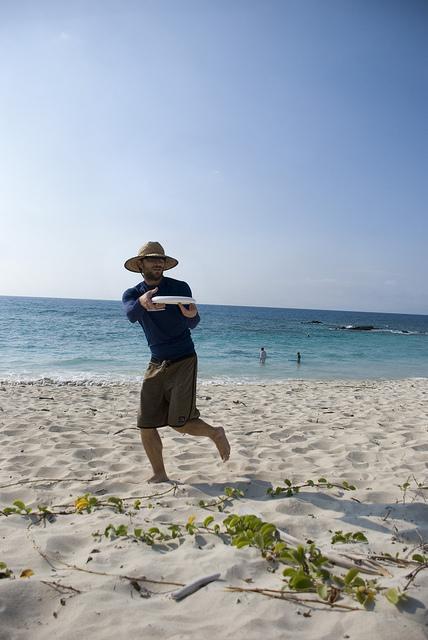How many people can you see?
Give a very brief answer. 1. 